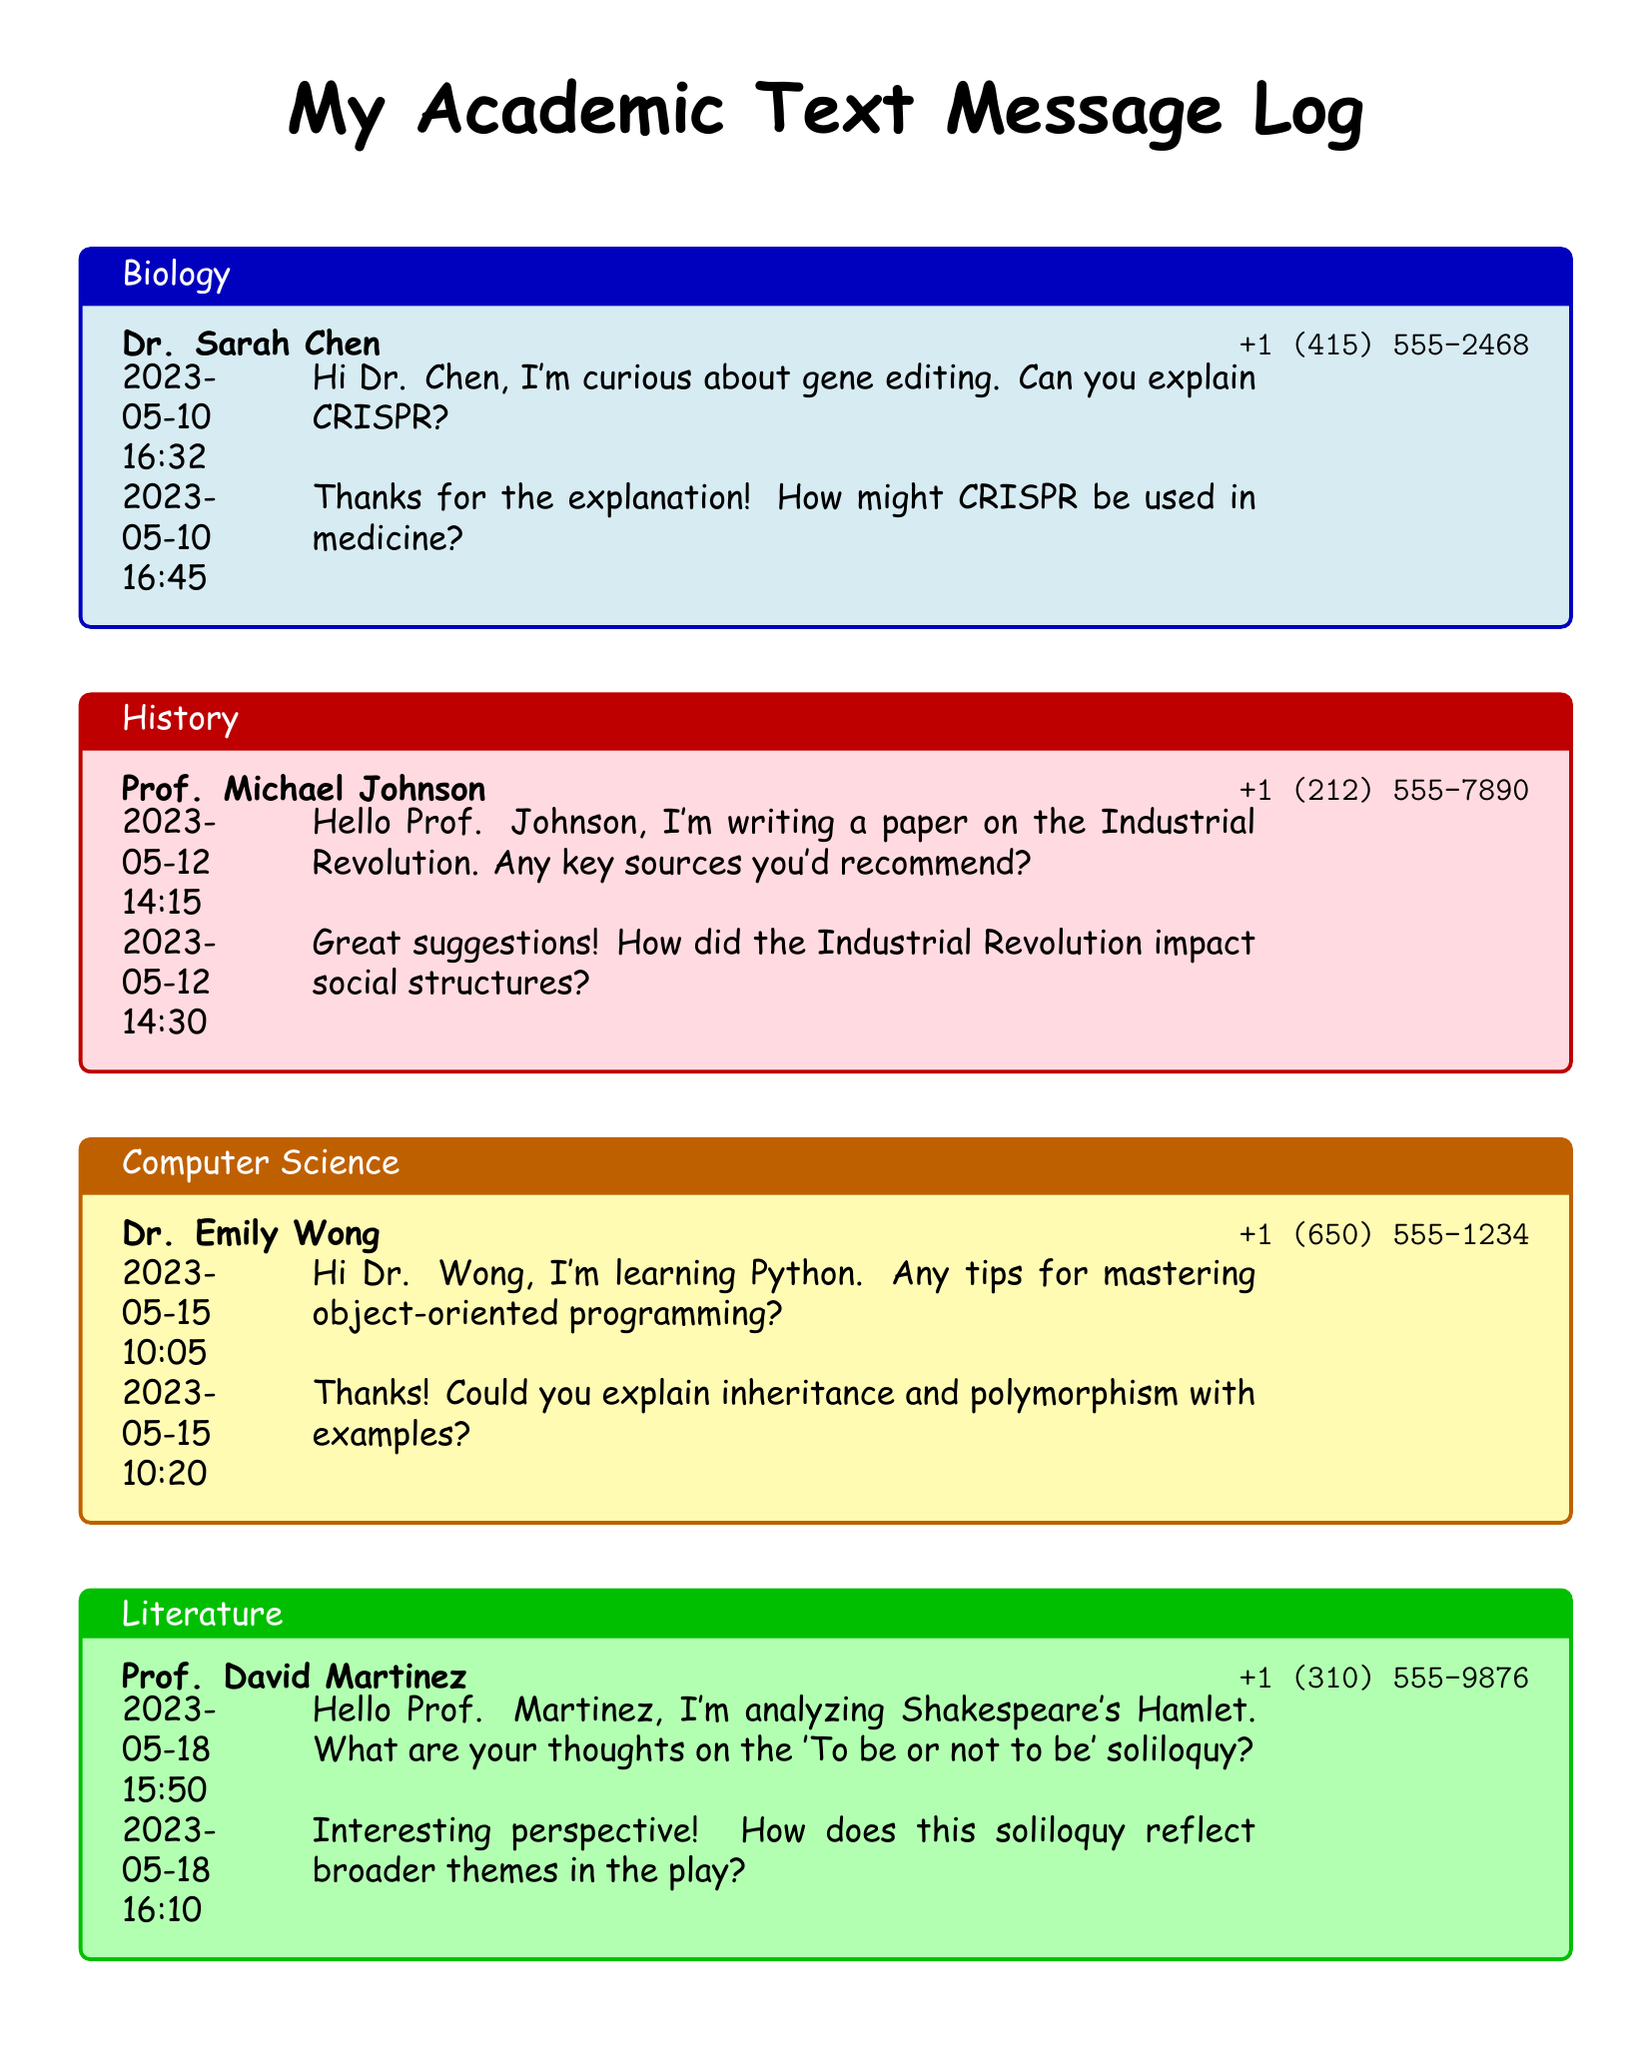What is the name of the Biology mentor? The document provides the name of the Biology mentor, which is Dr. Sarah Chen.
Answer: Dr. Sarah Chen What is the phone number of the Computer Science expert? The document lists the phone number of the Computer Science expert, which is +1 (650) 555-1234.
Answer: +1 (650) 555-1234 On what date did the text message exchange about the Industrial Revolution occur? The date for the text message exchange regarding the Industrial Revolution is provided as 2023-05-12.
Answer: 2023-05-12 Which academic discipline does Prof. David Martinez specialize in? The document specifies that Prof. David Martinez is categorized under Literature.
Answer: Literature What key concept did the Computer Science mentor explain? The Computer Science mentor discussed object-oriented programming as a key concept.
Answer: object-oriented programming How many text messages were sent in the Biology category? The document records two text messages exchanged in the Biology category.
Answer: 2 What is the last name of the History expert? The document mentions the last name of the History expert, which is Johnson.
Answer: Johnson What are the two programming concepts mentioned by Dr. Wong? The concepts discussed were inheritance and polymorphism as mentioned by Dr. Wong.
Answer: inheritance and polymorphism What time did the message about Shakespeare's Hamlet get sent? The message about Shakespeare's Hamlet was sent at 15:50.
Answer: 15:50 